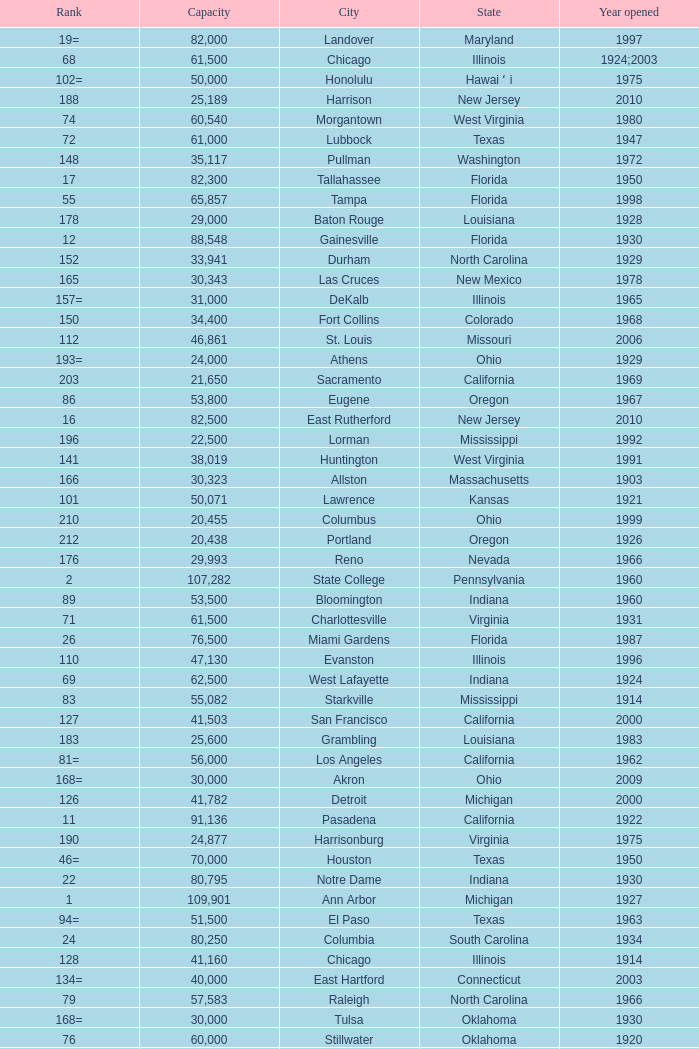What is the city in Alabama that opened in 1996? Huntsville. 